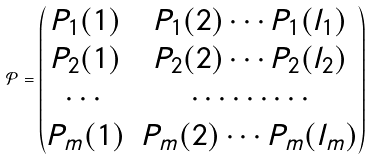<formula> <loc_0><loc_0><loc_500><loc_500>\mathcal { P } = \begin{pmatrix} P _ { 1 } ( 1 ) & P _ { 1 } ( 2 ) \cdots P _ { 1 } ( l _ { 1 } ) \\ P _ { 2 } ( 1 ) & P _ { 2 } ( 2 ) \cdots P _ { 2 } ( l _ { 2 } ) \\ \cdots & \cdots \cdots \cdots \\ P _ { m } ( 1 ) & P _ { m } ( 2 ) \cdots P _ { m } ( l _ { m } ) \end{pmatrix}</formula> 